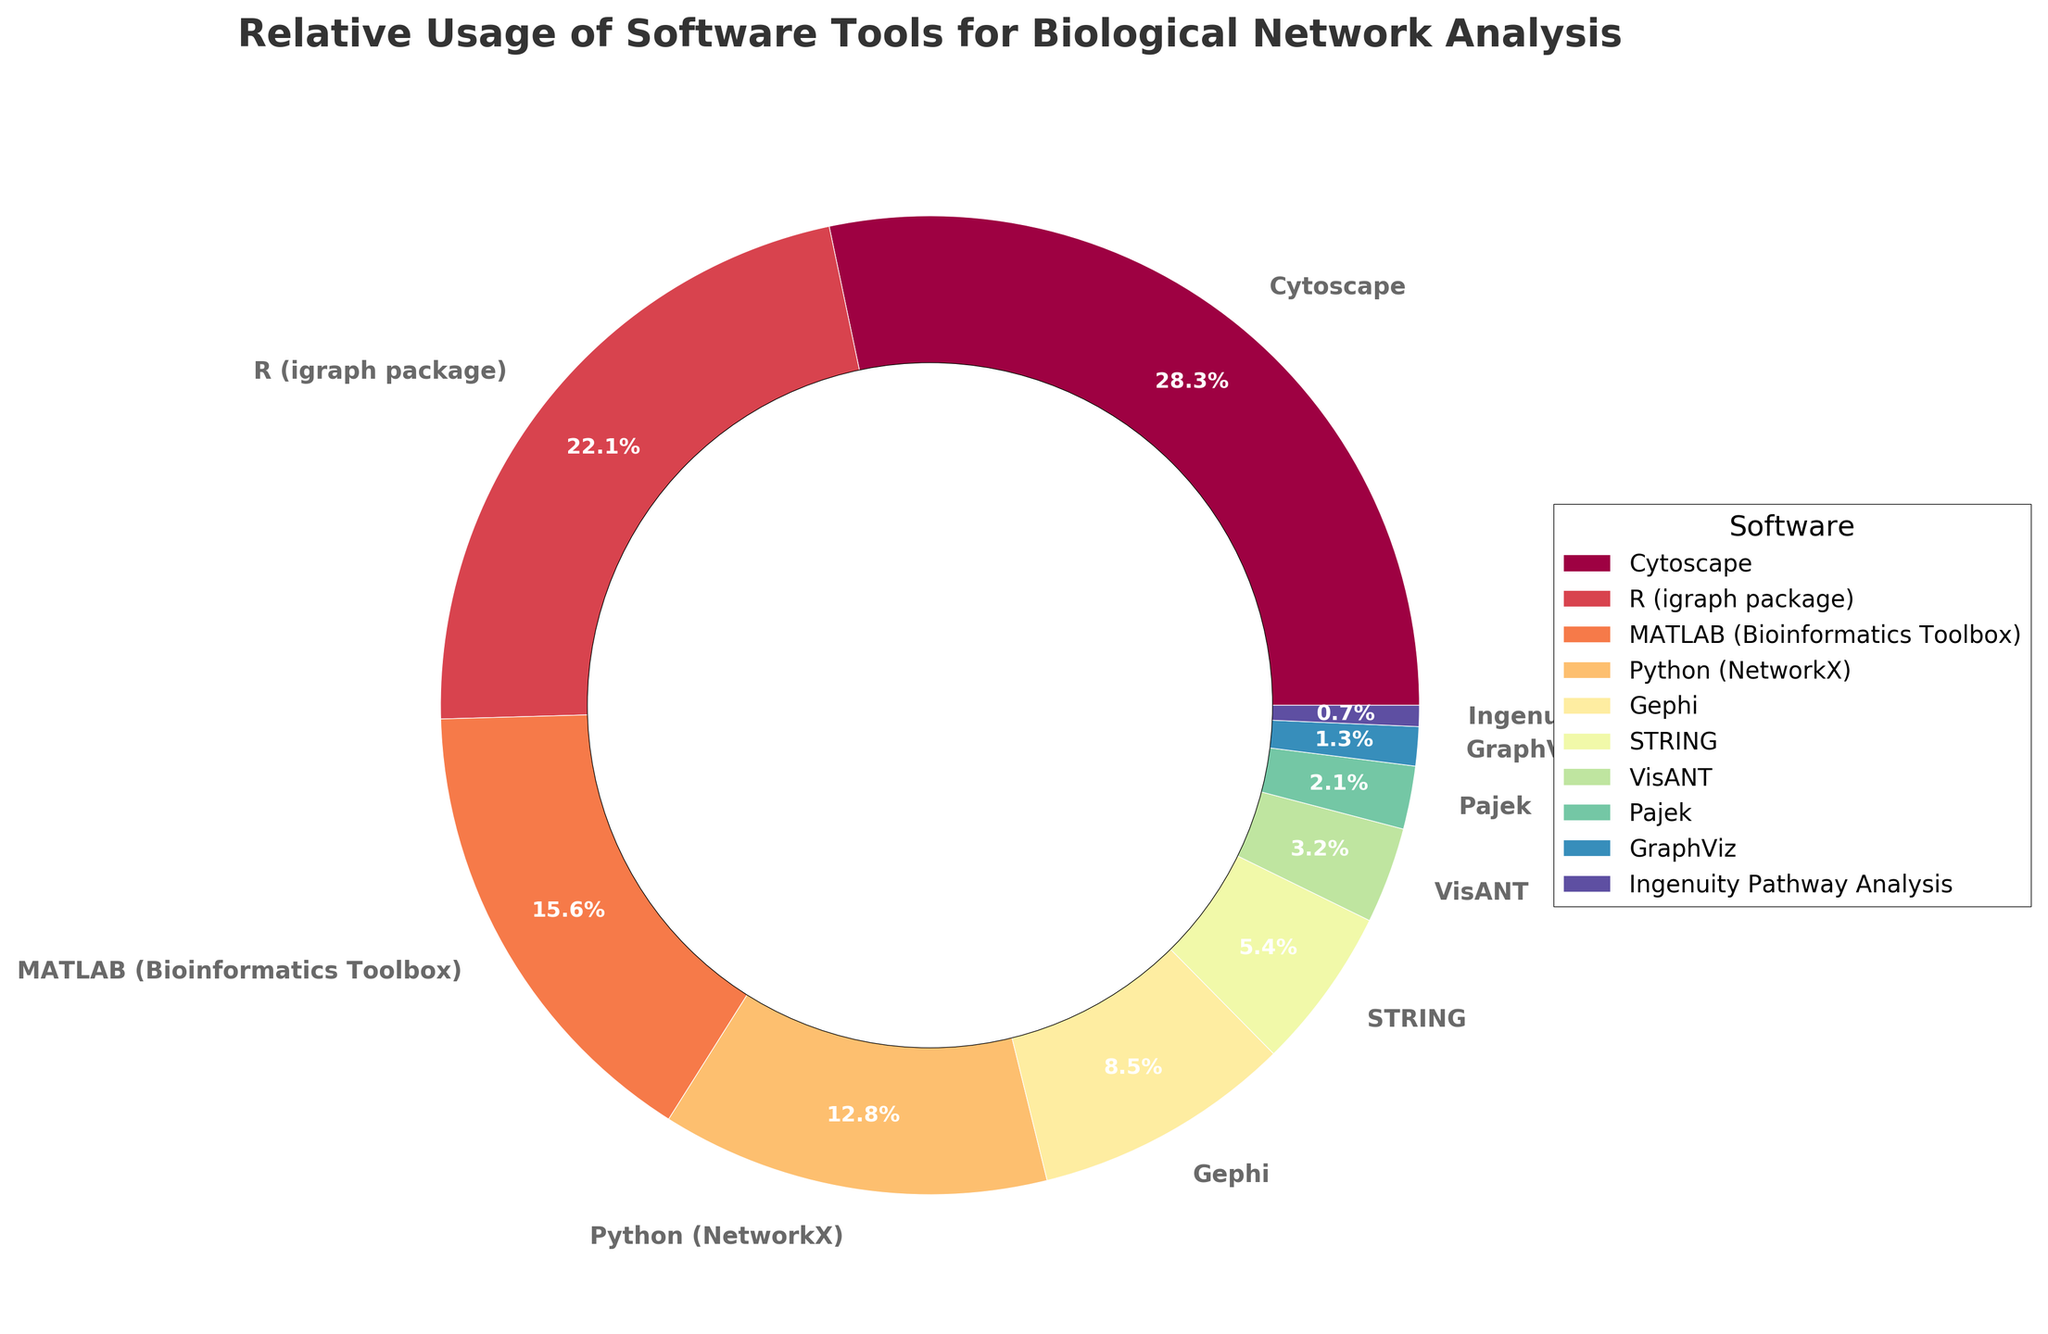Which software tool has the highest percentage of usage? To find the software tool with the highest percentage of usage, look for the largest section of the pie chart. Cytoscape occupies the largest section.
Answer: Cytoscape Which software tools collectively account for more than 50% of the total usage? Identify the software tools and their percentages and then sum the largest ones until the cumulative sum exceeds 50%. Cytoscape (28.5%), R (igraph package) (22.3%) together sum up to 50.8%.
Answer: Cytoscape, R (igraph package) What is the percentage difference between the usage of Python (NetworkX) and MATLAB (Bioinformatics Toolbox)? Find the percentages for both Python (NetworkX) and MATLAB (Bioinformatics Toolbox), then subtract the smaller percentage from the larger one. MATLAB (15.7%) - Python (12.9%) = 2.8%.
Answer: 2.8% Which software tools have a similar level of usage, near 5%? Look for software tools with percentages close to 5%. STRING (5.4%) and VisANT (3.2%) are relatively close to 5%.
Answer: STRING, VisANT Which tool has the least usage, and what percentage does it have? Identify the smallest section of the pie chart by looking at the corresponding labels. Ingenuity Pathway Analysis has the smallest section.
Answer: Ingenuity Pathway Analysis, 0.7% What is the combined percentage of Gephi, Pajek, and GraphViz? Add the percentages of Gephi (8.6%), Pajek (2.1%), and GraphViz (1.3%). 8.6% + 2.1% + 1.3% = 12.0%.
Answer: 12.0% How does the usage of Cytoscape compare to the total of the four least used tools? Identify the least used tools and their percentages: Ingenuity Pathway Analysis (0.7%), GraphViz (1.3%), Pajek (2.1%), VisANT (3.2%). Sum them up and compare it to Cytoscape's percentage. 0.7% + 1.3% + 2.1% + 3.2% = 7.3%. Cytoscape has a higher usage (28.5%) than their total.
Answer: Cytoscape has a higher usage Rank the software tools from most to least used. Order the tools based on their percentage of usage in descending order.
Answer: Cytoscape, R (igraph package), MATLAB (Bioinformatics Toolbox), Python (NetworkX), Gephi, STRING, VisANT, Pajek, GraphViz, Ingenuity Pathway Analysis Which visual attribute indicates that a software tool has a higher usage? Observe which attribute differentiates the sectors in the pie chart. Larger sectors indicate higher usage.
Answer: Larger sector 